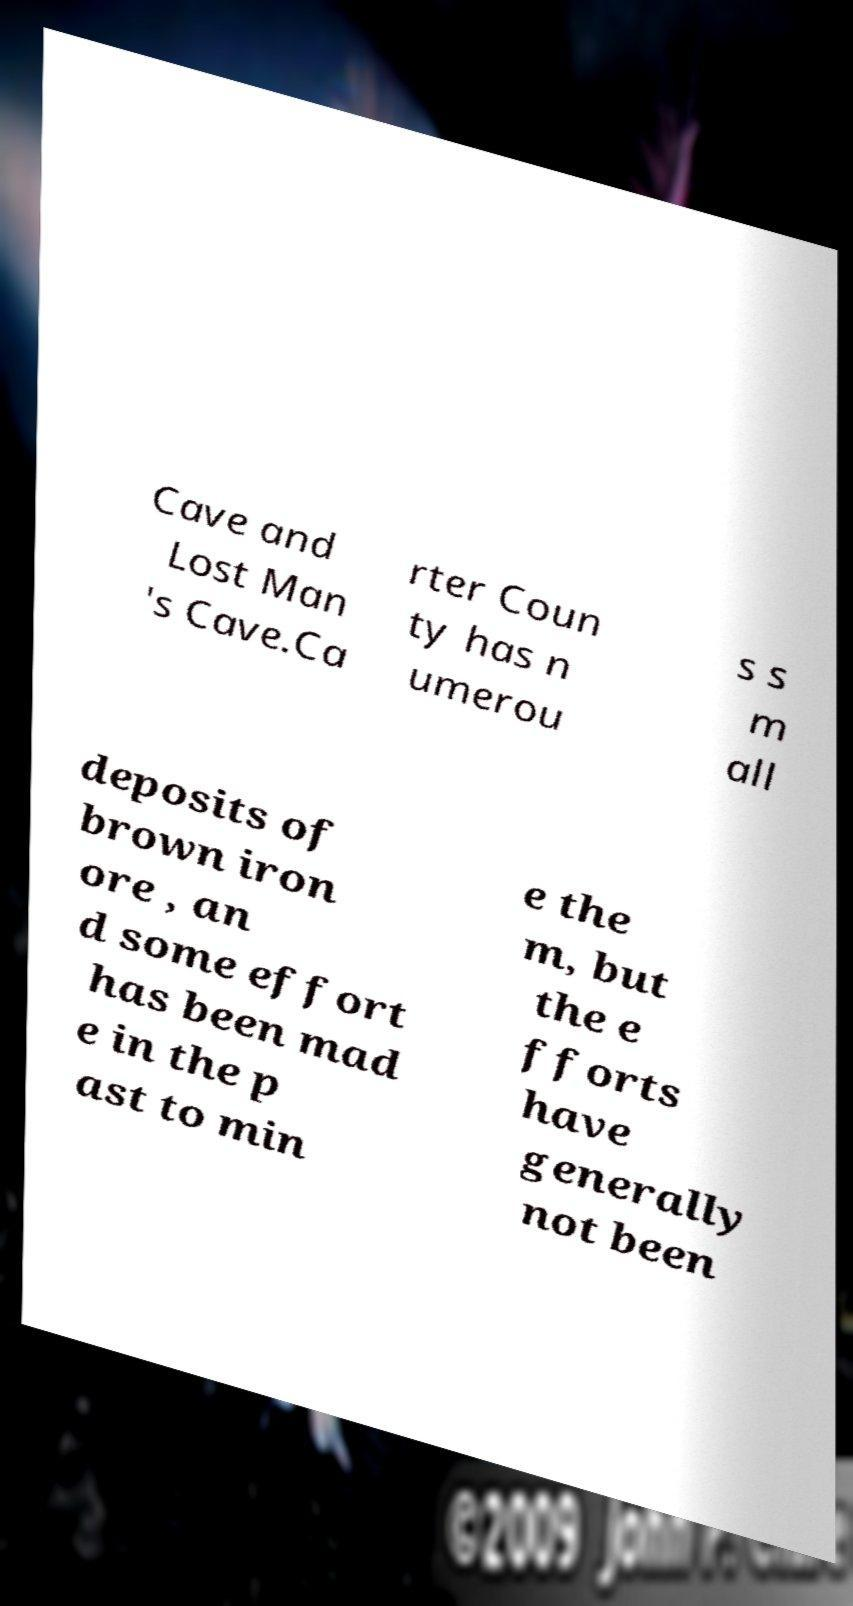Please read and relay the text visible in this image. What does it say? Cave and Lost Man 's Cave.Ca rter Coun ty has n umerou s s m all deposits of brown iron ore , an d some effort has been mad e in the p ast to min e the m, but the e fforts have generally not been 